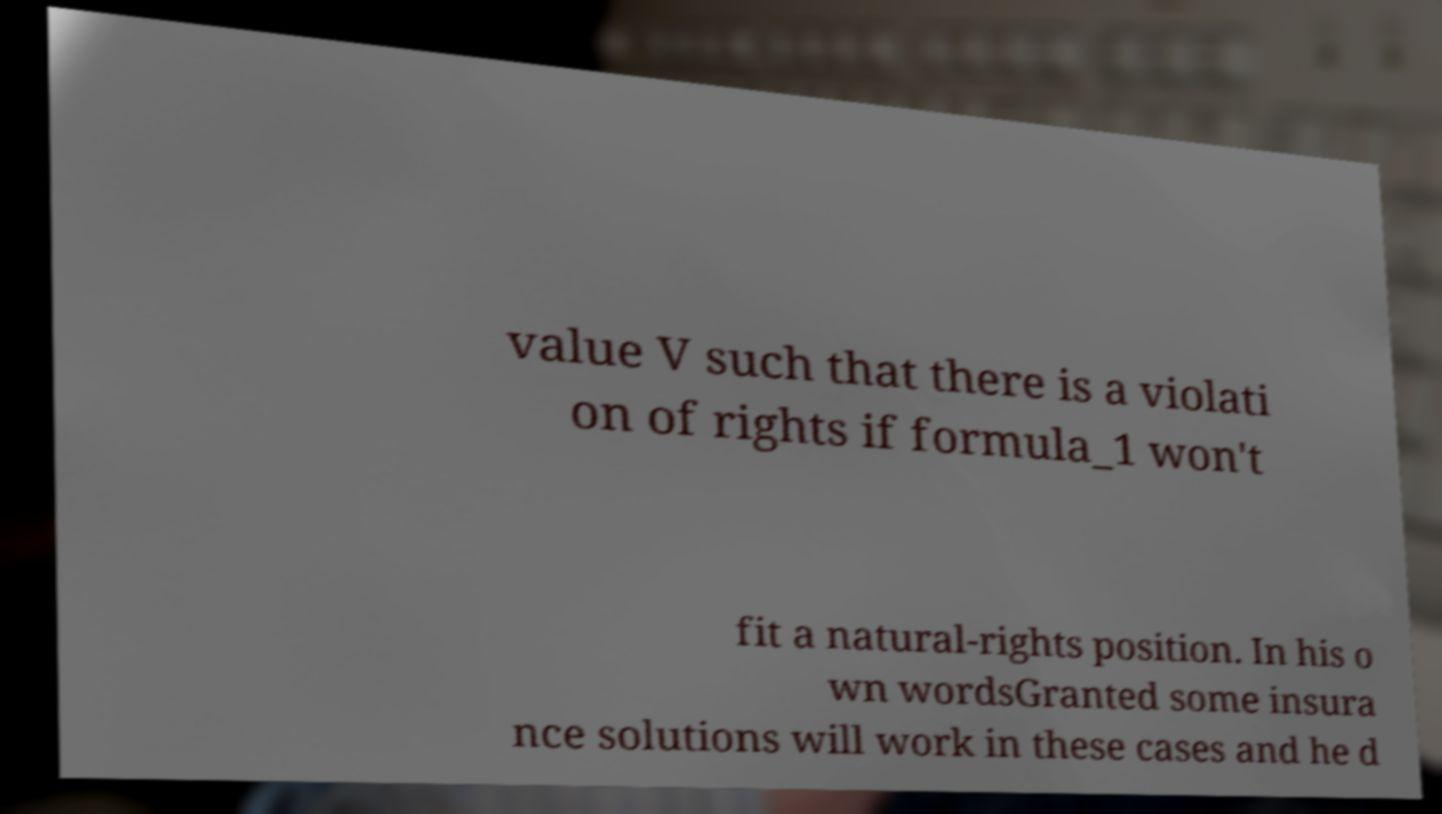Can you read and provide the text displayed in the image?This photo seems to have some interesting text. Can you extract and type it out for me? value V such that there is a violati on of rights if formula_1 won't fit a natural-rights position. In his o wn wordsGranted some insura nce solutions will work in these cases and he d 